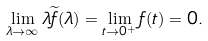Convert formula to latex. <formula><loc_0><loc_0><loc_500><loc_500>\lim _ { \lambda \to \infty } \lambda \widetilde { f } ( \lambda ) = \lim _ { t \to 0 ^ { + } } f ( t ) = 0 .</formula> 